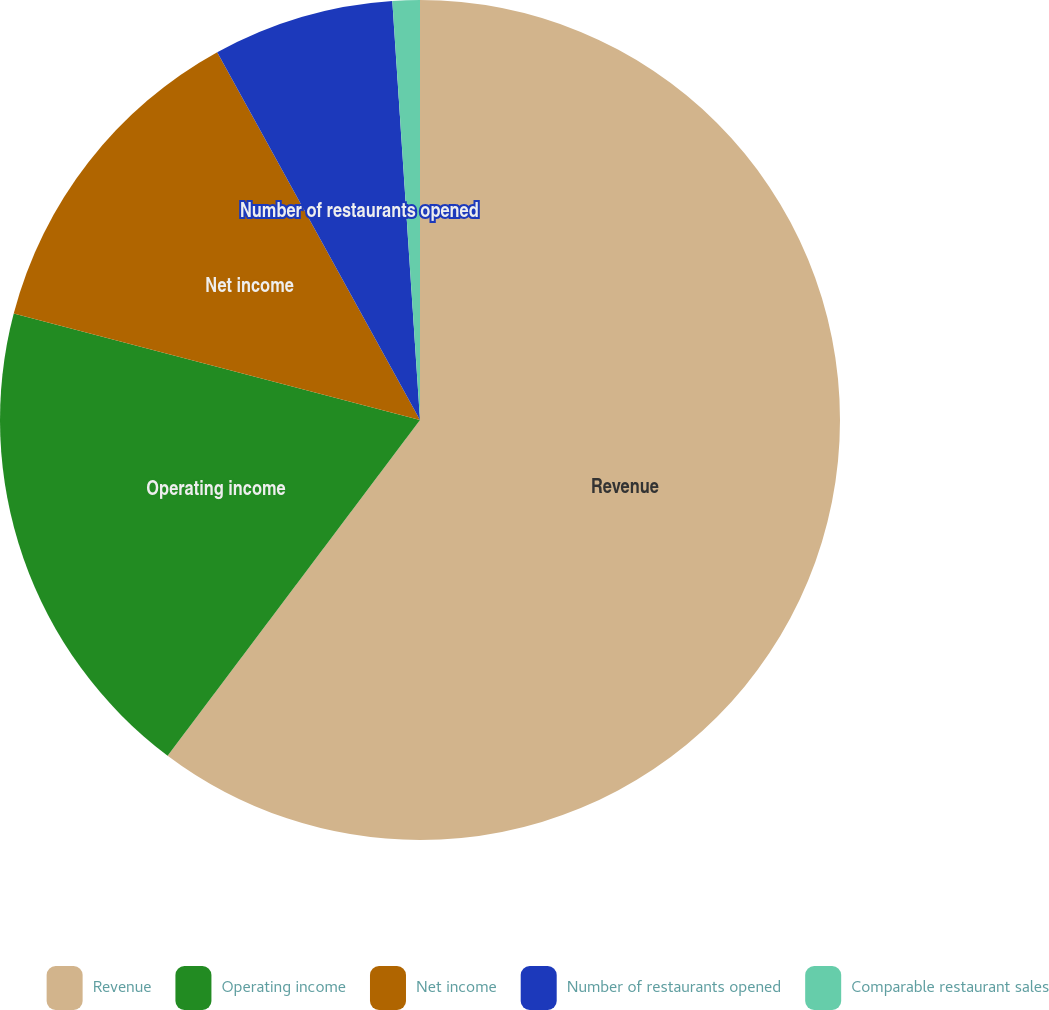<chart> <loc_0><loc_0><loc_500><loc_500><pie_chart><fcel>Revenue<fcel>Operating income<fcel>Net income<fcel>Number of restaurants opened<fcel>Comparable restaurant sales<nl><fcel>60.26%<fcel>18.82%<fcel>12.9%<fcel>6.97%<fcel>1.05%<nl></chart> 